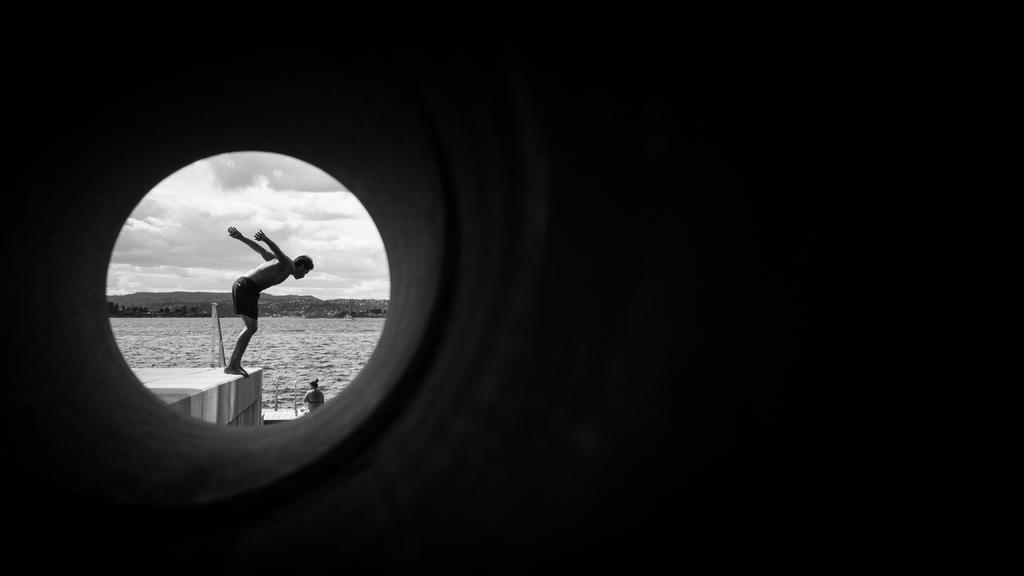In one or two sentences, can you explain what this image depicts? In this image I can see a man and a woman in the front. In the background I can see water, number of trees, clouds, the sky and I can also see this image is black and white in colour. 